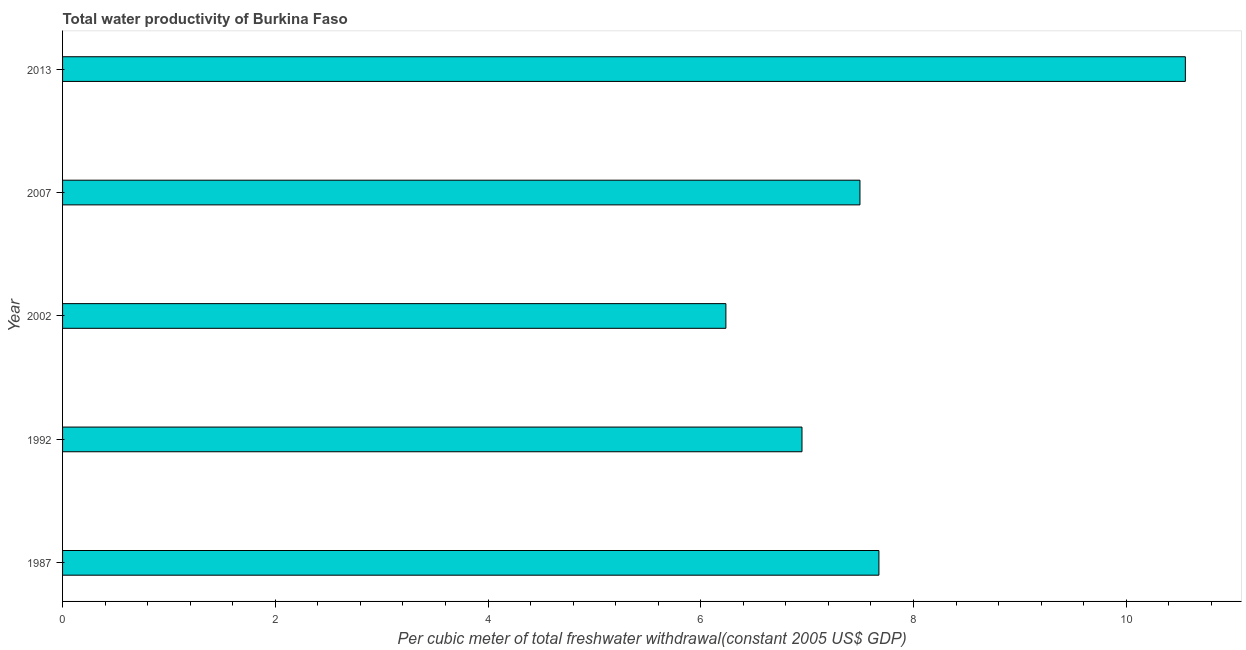What is the title of the graph?
Keep it short and to the point. Total water productivity of Burkina Faso. What is the label or title of the X-axis?
Your answer should be compact. Per cubic meter of total freshwater withdrawal(constant 2005 US$ GDP). What is the label or title of the Y-axis?
Offer a very short reply. Year. What is the total water productivity in 1992?
Give a very brief answer. 6.95. Across all years, what is the maximum total water productivity?
Ensure brevity in your answer.  10.56. Across all years, what is the minimum total water productivity?
Keep it short and to the point. 6.24. In which year was the total water productivity maximum?
Offer a terse response. 2013. What is the sum of the total water productivity?
Make the answer very short. 38.92. What is the difference between the total water productivity in 1987 and 2007?
Your response must be concise. 0.18. What is the average total water productivity per year?
Your answer should be compact. 7.78. What is the median total water productivity?
Provide a short and direct response. 7.5. What is the ratio of the total water productivity in 1987 to that in 1992?
Your answer should be very brief. 1.1. Is the difference between the total water productivity in 1987 and 2013 greater than the difference between any two years?
Offer a very short reply. No. What is the difference between the highest and the second highest total water productivity?
Provide a short and direct response. 2.88. Is the sum of the total water productivity in 2002 and 2013 greater than the maximum total water productivity across all years?
Provide a short and direct response. Yes. What is the difference between the highest and the lowest total water productivity?
Your response must be concise. 4.32. In how many years, is the total water productivity greater than the average total water productivity taken over all years?
Provide a short and direct response. 1. How many bars are there?
Make the answer very short. 5. How many years are there in the graph?
Provide a succinct answer. 5. What is the Per cubic meter of total freshwater withdrawal(constant 2005 US$ GDP) of 1987?
Ensure brevity in your answer.  7.68. What is the Per cubic meter of total freshwater withdrawal(constant 2005 US$ GDP) of 1992?
Give a very brief answer. 6.95. What is the Per cubic meter of total freshwater withdrawal(constant 2005 US$ GDP) in 2002?
Ensure brevity in your answer.  6.24. What is the Per cubic meter of total freshwater withdrawal(constant 2005 US$ GDP) in 2007?
Provide a succinct answer. 7.5. What is the Per cubic meter of total freshwater withdrawal(constant 2005 US$ GDP) in 2013?
Give a very brief answer. 10.56. What is the difference between the Per cubic meter of total freshwater withdrawal(constant 2005 US$ GDP) in 1987 and 1992?
Ensure brevity in your answer.  0.72. What is the difference between the Per cubic meter of total freshwater withdrawal(constant 2005 US$ GDP) in 1987 and 2002?
Keep it short and to the point. 1.44. What is the difference between the Per cubic meter of total freshwater withdrawal(constant 2005 US$ GDP) in 1987 and 2007?
Offer a very short reply. 0.18. What is the difference between the Per cubic meter of total freshwater withdrawal(constant 2005 US$ GDP) in 1987 and 2013?
Your answer should be very brief. -2.88. What is the difference between the Per cubic meter of total freshwater withdrawal(constant 2005 US$ GDP) in 1992 and 2002?
Your answer should be compact. 0.72. What is the difference between the Per cubic meter of total freshwater withdrawal(constant 2005 US$ GDP) in 1992 and 2007?
Offer a terse response. -0.55. What is the difference between the Per cubic meter of total freshwater withdrawal(constant 2005 US$ GDP) in 1992 and 2013?
Provide a succinct answer. -3.6. What is the difference between the Per cubic meter of total freshwater withdrawal(constant 2005 US$ GDP) in 2002 and 2007?
Your answer should be compact. -1.26. What is the difference between the Per cubic meter of total freshwater withdrawal(constant 2005 US$ GDP) in 2002 and 2013?
Ensure brevity in your answer.  -4.32. What is the difference between the Per cubic meter of total freshwater withdrawal(constant 2005 US$ GDP) in 2007 and 2013?
Ensure brevity in your answer.  -3.06. What is the ratio of the Per cubic meter of total freshwater withdrawal(constant 2005 US$ GDP) in 1987 to that in 1992?
Your response must be concise. 1.1. What is the ratio of the Per cubic meter of total freshwater withdrawal(constant 2005 US$ GDP) in 1987 to that in 2002?
Provide a succinct answer. 1.23. What is the ratio of the Per cubic meter of total freshwater withdrawal(constant 2005 US$ GDP) in 1987 to that in 2007?
Make the answer very short. 1.02. What is the ratio of the Per cubic meter of total freshwater withdrawal(constant 2005 US$ GDP) in 1987 to that in 2013?
Your answer should be compact. 0.73. What is the ratio of the Per cubic meter of total freshwater withdrawal(constant 2005 US$ GDP) in 1992 to that in 2002?
Offer a very short reply. 1.11. What is the ratio of the Per cubic meter of total freshwater withdrawal(constant 2005 US$ GDP) in 1992 to that in 2007?
Offer a very short reply. 0.93. What is the ratio of the Per cubic meter of total freshwater withdrawal(constant 2005 US$ GDP) in 1992 to that in 2013?
Make the answer very short. 0.66. What is the ratio of the Per cubic meter of total freshwater withdrawal(constant 2005 US$ GDP) in 2002 to that in 2007?
Give a very brief answer. 0.83. What is the ratio of the Per cubic meter of total freshwater withdrawal(constant 2005 US$ GDP) in 2002 to that in 2013?
Your answer should be very brief. 0.59. What is the ratio of the Per cubic meter of total freshwater withdrawal(constant 2005 US$ GDP) in 2007 to that in 2013?
Your answer should be compact. 0.71. 